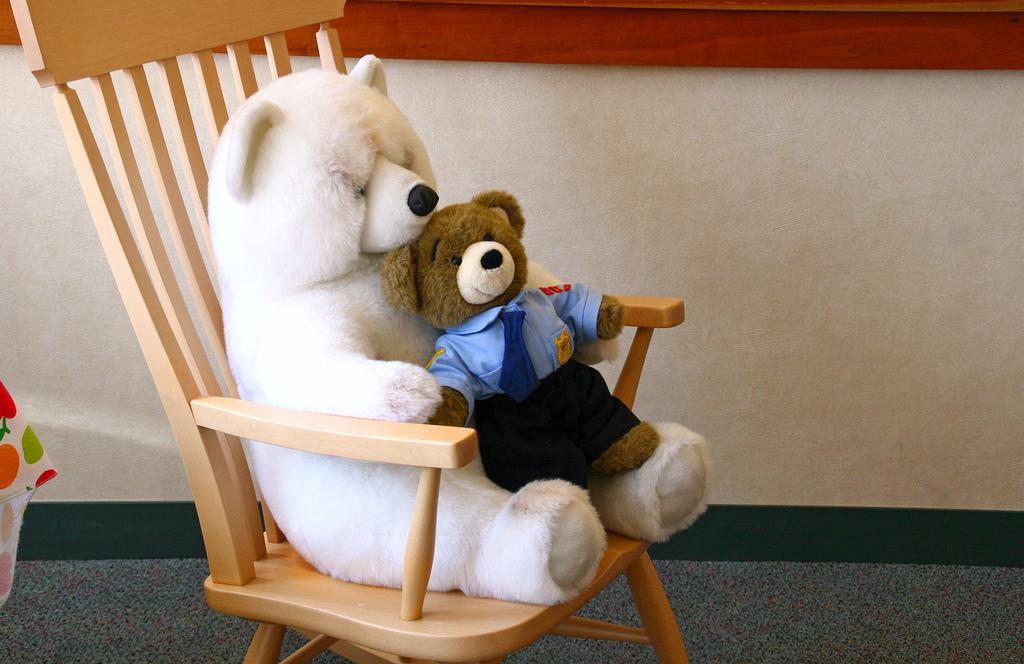What is located in the front of the image? There is a chair in the front of the image. What is on the chair? There are two teddy bears on the chair. What can be seen in the background of the image? There is a wall in the background of the image. What is on the left side of the image? There is a cloth on the left side of the image. How many girls are playing with the cart in the image? There is no cart or girls present in the image. What type of stove is visible in the image? There is no stove present in the image. 